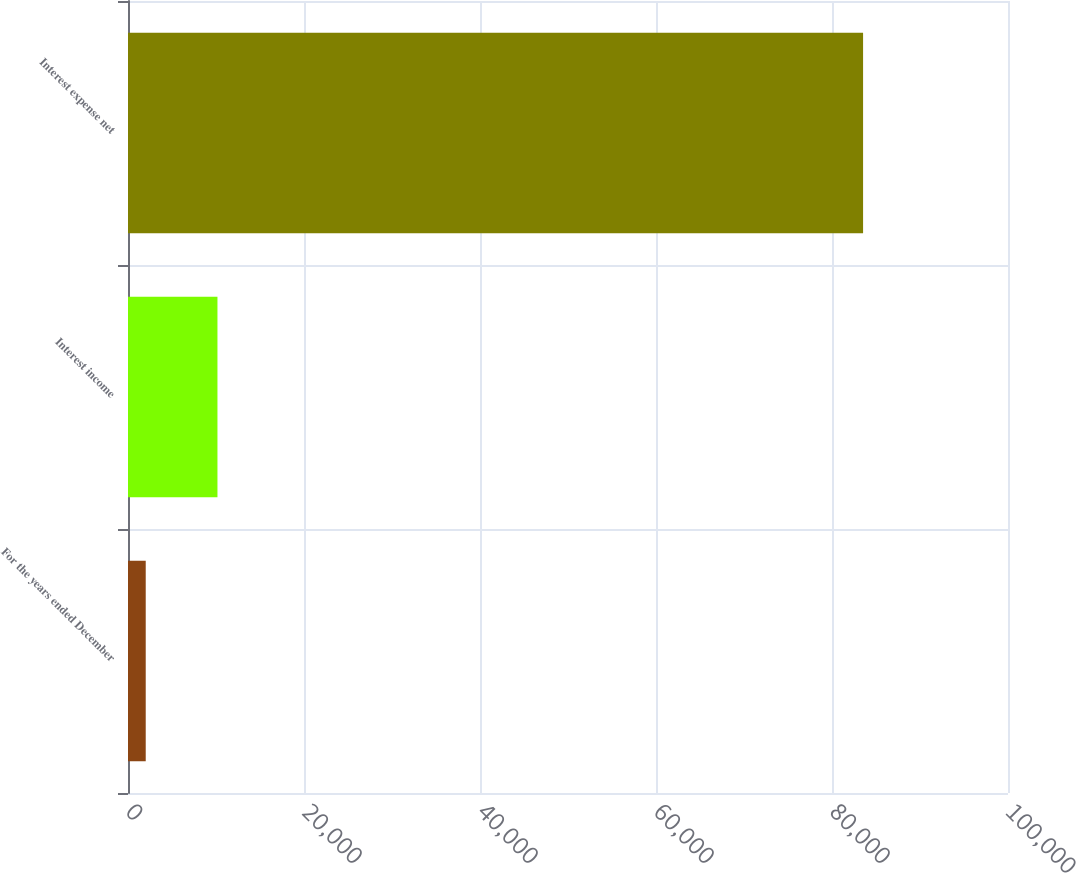Convert chart to OTSL. <chart><loc_0><loc_0><loc_500><loc_500><bar_chart><fcel>For the years ended December<fcel>Interest income<fcel>Interest expense net<nl><fcel>2014<fcel>10165.8<fcel>83532<nl></chart> 